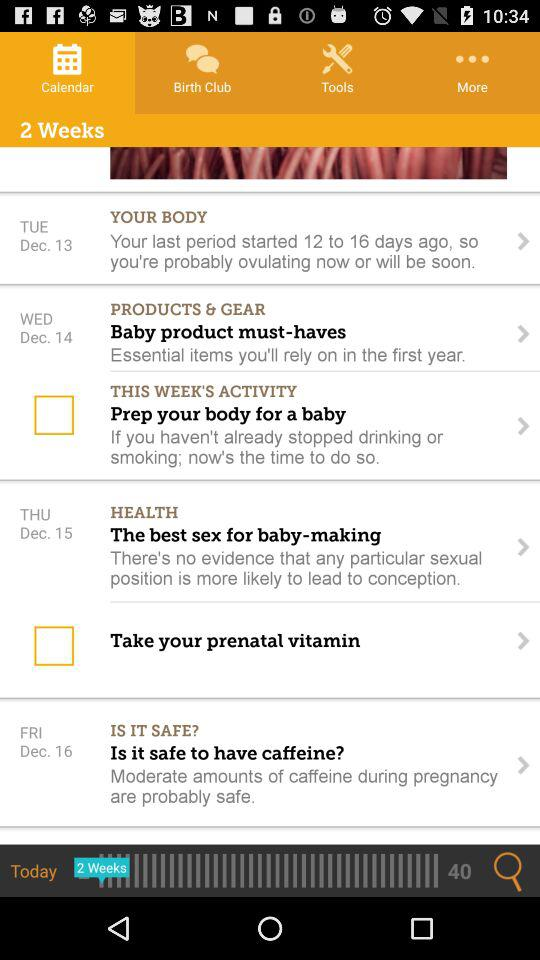What is the calendar year?
When the provided information is insufficient, respond with <no answer>. <no answer> 